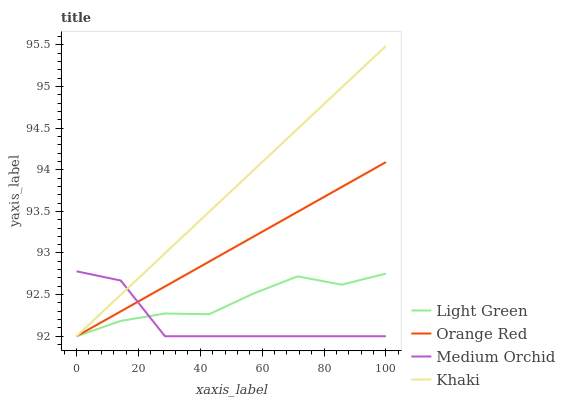Does Orange Red have the minimum area under the curve?
Answer yes or no. No. Does Orange Red have the maximum area under the curve?
Answer yes or no. No. Is Orange Red the smoothest?
Answer yes or no. No. Is Orange Red the roughest?
Answer yes or no. No. Does Orange Red have the highest value?
Answer yes or no. No. 